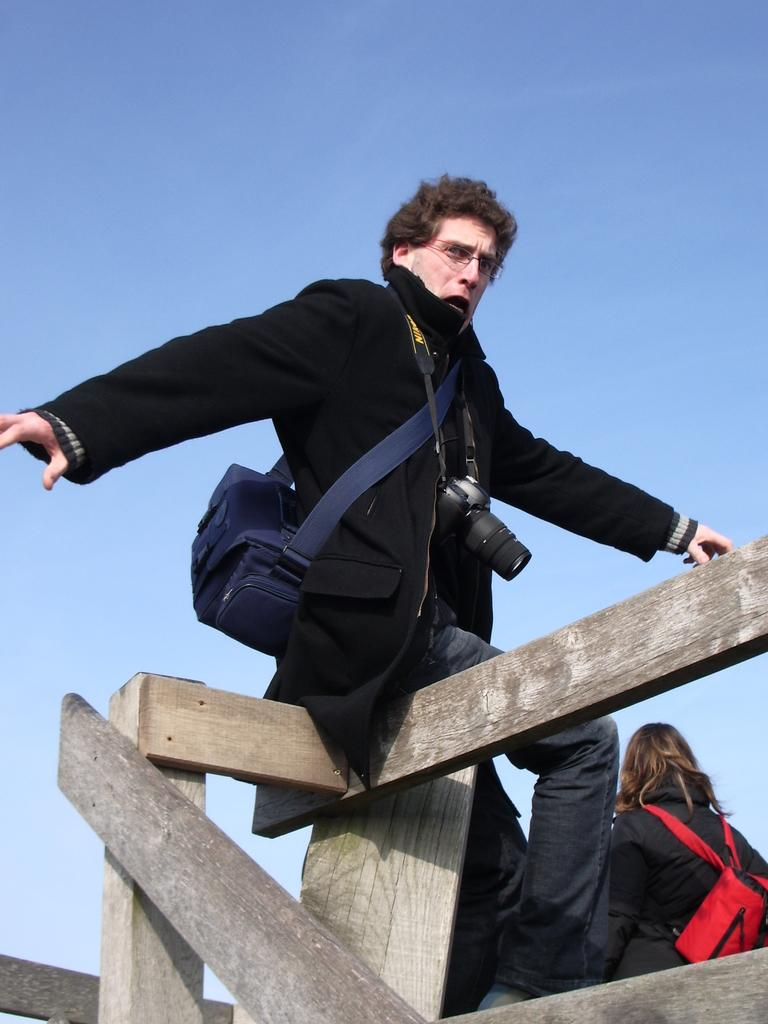What is the person in the image doing? The person is sitting in the image. What is the person sitting on? The person is sitting on a wooden object. What items is the person holding? The person is holding a bag and a camera. Can you describe the woman visible in the background? The woman is visible in the background, and she is wearing a red color bag. What type of pickle is the person eating in the image? There is no pickle present in the image. Is this a birthday celebration, given the presence of the person and the woman in the image? The image does not provide any information about a birthday celebration. 